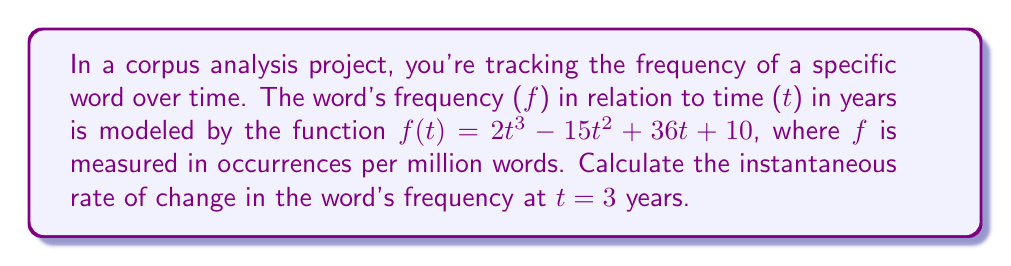Can you answer this question? To find the instantaneous rate of change at t = 3, we need to calculate the derivative of the function f(t) and then evaluate it at t = 3.

Step 1: Find the derivative of f(t)
$$f(t) = 2t^3 - 15t^2 + 36t + 10$$
$$f'(t) = 6t^2 - 30t + 36$$

Step 2: Evaluate f'(t) at t = 3
$$f'(3) = 6(3)^2 - 30(3) + 36$$
$$f'(3) = 6(9) - 90 + 36$$
$$f'(3) = 54 - 90 + 36$$
$$f'(3) = 0$$

The instantaneous rate of change at t = 3 is 0 occurrences per million words per year.
Answer: 0 occurrences per million words per year 